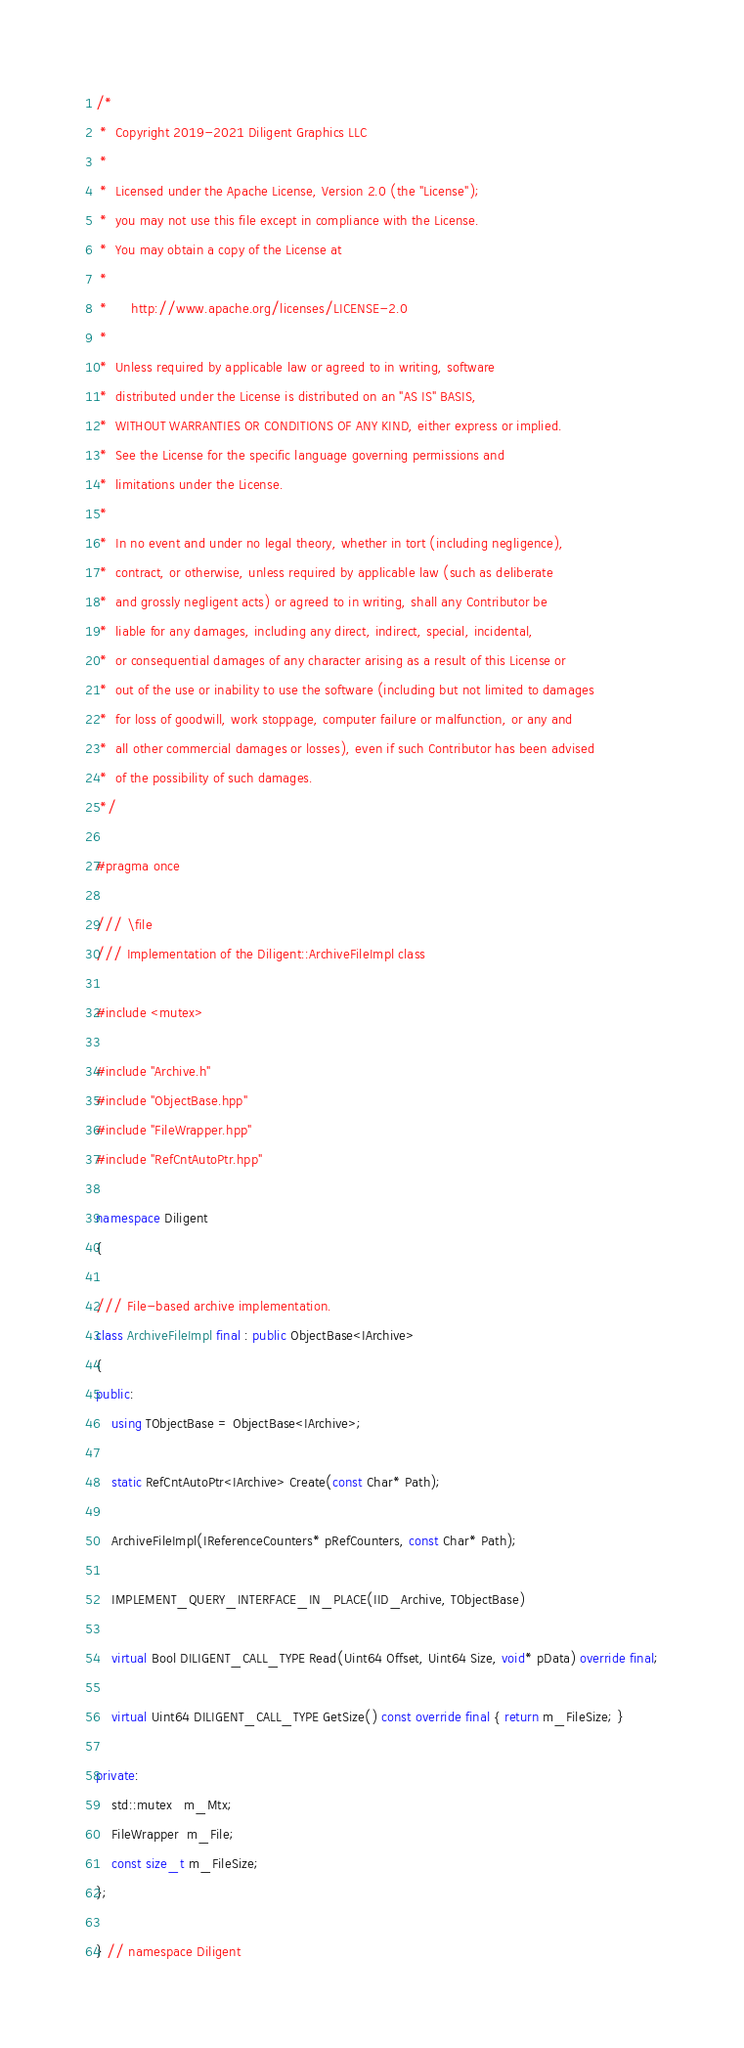<code> <loc_0><loc_0><loc_500><loc_500><_C++_>/*
 *  Copyright 2019-2021 Diligent Graphics LLC
 *
 *  Licensed under the Apache License, Version 2.0 (the "License");
 *  you may not use this file except in compliance with the License.
 *  You may obtain a copy of the License at
 *
 *      http://www.apache.org/licenses/LICENSE-2.0
 *
 *  Unless required by applicable law or agreed to in writing, software
 *  distributed under the License is distributed on an "AS IS" BASIS,
 *  WITHOUT WARRANTIES OR CONDITIONS OF ANY KIND, either express or implied.
 *  See the License for the specific language governing permissions and
 *  limitations under the License.
 *
 *  In no event and under no legal theory, whether in tort (including negligence),
 *  contract, or otherwise, unless required by applicable law (such as deliberate
 *  and grossly negligent acts) or agreed to in writing, shall any Contributor be
 *  liable for any damages, including any direct, indirect, special, incidental,
 *  or consequential damages of any character arising as a result of this License or
 *  out of the use or inability to use the software (including but not limited to damages
 *  for loss of goodwill, work stoppage, computer failure or malfunction, or any and
 *  all other commercial damages or losses), even if such Contributor has been advised
 *  of the possibility of such damages.
 */

#pragma once

/// \file
/// Implementation of the Diligent::ArchiveFileImpl class

#include <mutex>

#include "Archive.h"
#include "ObjectBase.hpp"
#include "FileWrapper.hpp"
#include "RefCntAutoPtr.hpp"

namespace Diligent
{

/// File-based archive implementation.
class ArchiveFileImpl final : public ObjectBase<IArchive>
{
public:
    using TObjectBase = ObjectBase<IArchive>;

    static RefCntAutoPtr<IArchive> Create(const Char* Path);

    ArchiveFileImpl(IReferenceCounters* pRefCounters, const Char* Path);

    IMPLEMENT_QUERY_INTERFACE_IN_PLACE(IID_Archive, TObjectBase)

    virtual Bool DILIGENT_CALL_TYPE Read(Uint64 Offset, Uint64 Size, void* pData) override final;

    virtual Uint64 DILIGENT_CALL_TYPE GetSize() const override final { return m_FileSize; }

private:
    std::mutex   m_Mtx;
    FileWrapper  m_File;
    const size_t m_FileSize;
};

} // namespace Diligent
</code> 